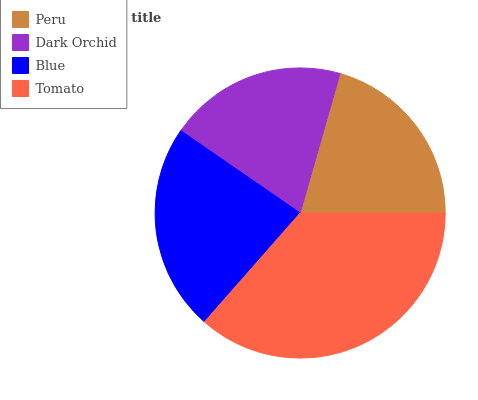Is Dark Orchid the minimum?
Answer yes or no. Yes. Is Tomato the maximum?
Answer yes or no. Yes. Is Blue the minimum?
Answer yes or no. No. Is Blue the maximum?
Answer yes or no. No. Is Blue greater than Dark Orchid?
Answer yes or no. Yes. Is Dark Orchid less than Blue?
Answer yes or no. Yes. Is Dark Orchid greater than Blue?
Answer yes or no. No. Is Blue less than Dark Orchid?
Answer yes or no. No. Is Blue the high median?
Answer yes or no. Yes. Is Peru the low median?
Answer yes or no. Yes. Is Dark Orchid the high median?
Answer yes or no. No. Is Dark Orchid the low median?
Answer yes or no. No. 